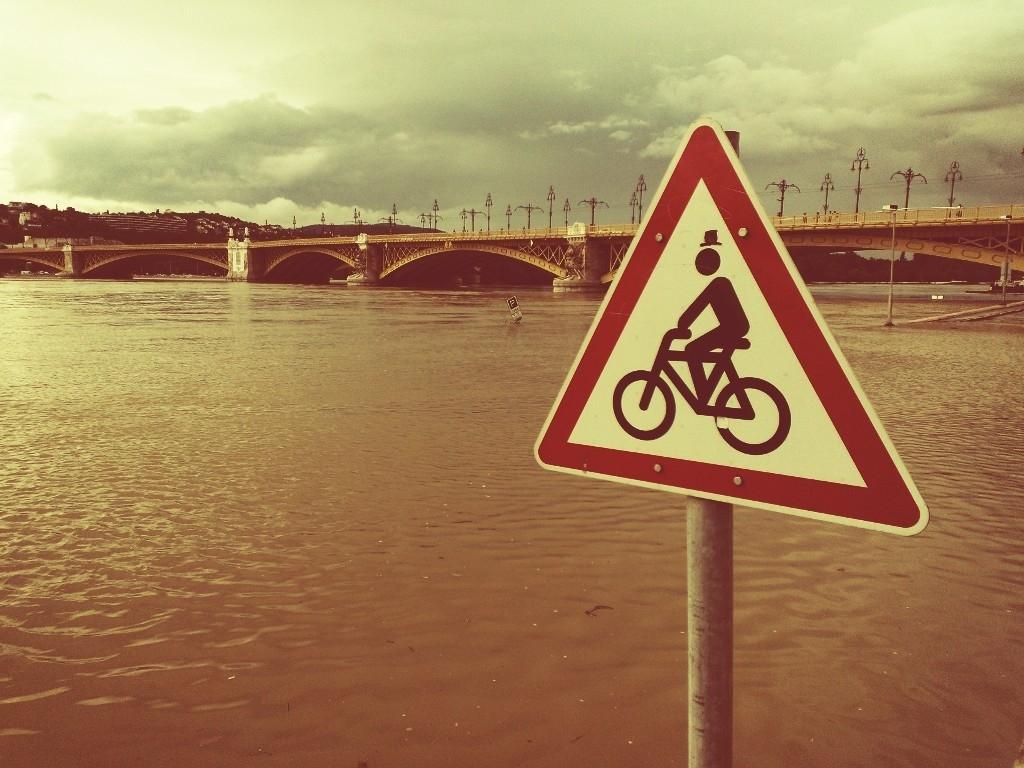In one or two sentences, can you explain what this image depicts? In this image there is a river and there is a bridge across the river, in the background there is a sky, on the left there is a pole to that pole there is a sign board. 